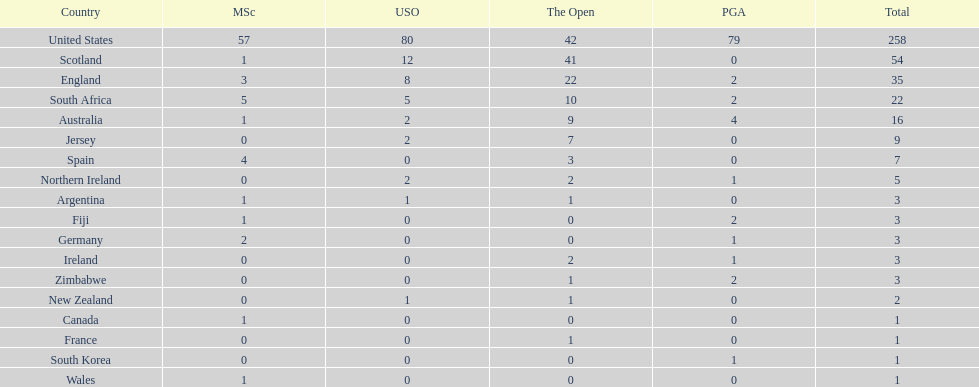Which country has the most pga championships. United States. 